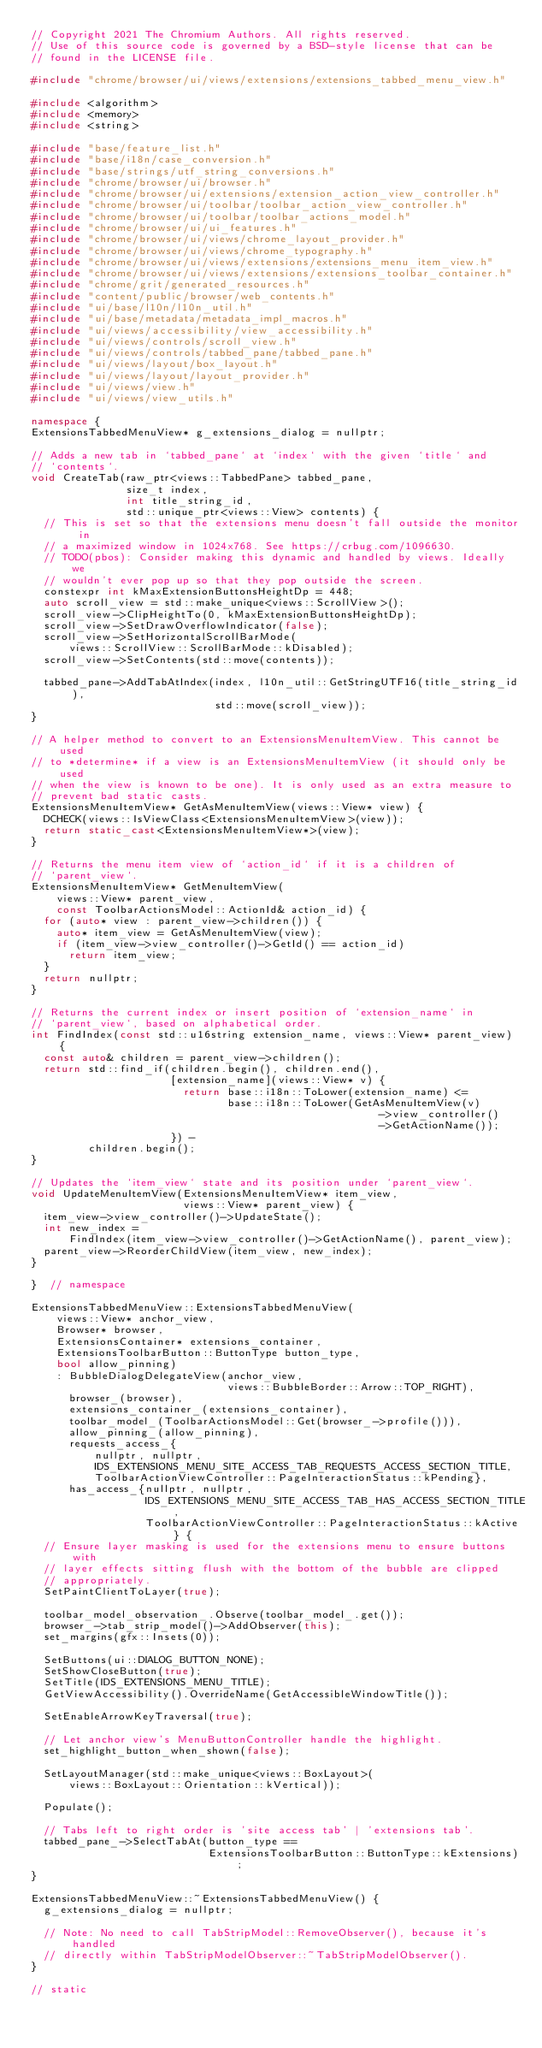Convert code to text. <code><loc_0><loc_0><loc_500><loc_500><_C++_>// Copyright 2021 The Chromium Authors. All rights reserved.
// Use of this source code is governed by a BSD-style license that can be
// found in the LICENSE file.

#include "chrome/browser/ui/views/extensions/extensions_tabbed_menu_view.h"

#include <algorithm>
#include <memory>
#include <string>

#include "base/feature_list.h"
#include "base/i18n/case_conversion.h"
#include "base/strings/utf_string_conversions.h"
#include "chrome/browser/ui/browser.h"
#include "chrome/browser/ui/extensions/extension_action_view_controller.h"
#include "chrome/browser/ui/toolbar/toolbar_action_view_controller.h"
#include "chrome/browser/ui/toolbar/toolbar_actions_model.h"
#include "chrome/browser/ui/ui_features.h"
#include "chrome/browser/ui/views/chrome_layout_provider.h"
#include "chrome/browser/ui/views/chrome_typography.h"
#include "chrome/browser/ui/views/extensions/extensions_menu_item_view.h"
#include "chrome/browser/ui/views/extensions/extensions_toolbar_container.h"
#include "chrome/grit/generated_resources.h"
#include "content/public/browser/web_contents.h"
#include "ui/base/l10n/l10n_util.h"
#include "ui/base/metadata/metadata_impl_macros.h"
#include "ui/views/accessibility/view_accessibility.h"
#include "ui/views/controls/scroll_view.h"
#include "ui/views/controls/tabbed_pane/tabbed_pane.h"
#include "ui/views/layout/box_layout.h"
#include "ui/views/layout/layout_provider.h"
#include "ui/views/view.h"
#include "ui/views/view_utils.h"

namespace {
ExtensionsTabbedMenuView* g_extensions_dialog = nullptr;

// Adds a new tab in `tabbed_pane` at `index` with the given `title` and
// `contents`.
void CreateTab(raw_ptr<views::TabbedPane> tabbed_pane,
               size_t index,
               int title_string_id,
               std::unique_ptr<views::View> contents) {
  // This is set so that the extensions menu doesn't fall outside the monitor in
  // a maximized window in 1024x768. See https://crbug.com/1096630.
  // TODO(pbos): Consider making this dynamic and handled by views. Ideally we
  // wouldn't ever pop up so that they pop outside the screen.
  constexpr int kMaxExtensionButtonsHeightDp = 448;
  auto scroll_view = std::make_unique<views::ScrollView>();
  scroll_view->ClipHeightTo(0, kMaxExtensionButtonsHeightDp);
  scroll_view->SetDrawOverflowIndicator(false);
  scroll_view->SetHorizontalScrollBarMode(
      views::ScrollView::ScrollBarMode::kDisabled);
  scroll_view->SetContents(std::move(contents));

  tabbed_pane->AddTabAtIndex(index, l10n_util::GetStringUTF16(title_string_id),
                             std::move(scroll_view));
}

// A helper method to convert to an ExtensionsMenuItemView. This cannot be used
// to *determine* if a view is an ExtensionsMenuItemView (it should only be used
// when the view is known to be one). It is only used as an extra measure to
// prevent bad static casts.
ExtensionsMenuItemView* GetAsMenuItemView(views::View* view) {
  DCHECK(views::IsViewClass<ExtensionsMenuItemView>(view));
  return static_cast<ExtensionsMenuItemView*>(view);
}

// Returns the menu item view of `action_id` if it is a children of
// `parent_view`.
ExtensionsMenuItemView* GetMenuItemView(
    views::View* parent_view,
    const ToolbarActionsModel::ActionId& action_id) {
  for (auto* view : parent_view->children()) {
    auto* item_view = GetAsMenuItemView(view);
    if (item_view->view_controller()->GetId() == action_id)
      return item_view;
  }
  return nullptr;
}

// Returns the current index or insert position of `extension_name` in
// `parent_view`, based on alphabetical order.
int FindIndex(const std::u16string extension_name, views::View* parent_view) {
  const auto& children = parent_view->children();
  return std::find_if(children.begin(), children.end(),
                      [extension_name](views::View* v) {
                        return base::i18n::ToLower(extension_name) <=
                               base::i18n::ToLower(GetAsMenuItemView(v)
                                                       ->view_controller()
                                                       ->GetActionName());
                      }) -
         children.begin();
}

// Updates the `item_view` state and its position under `parent_view`.
void UpdateMenuItemView(ExtensionsMenuItemView* item_view,
                        views::View* parent_view) {
  item_view->view_controller()->UpdateState();
  int new_index =
      FindIndex(item_view->view_controller()->GetActionName(), parent_view);
  parent_view->ReorderChildView(item_view, new_index);
}

}  // namespace

ExtensionsTabbedMenuView::ExtensionsTabbedMenuView(
    views::View* anchor_view,
    Browser* browser,
    ExtensionsContainer* extensions_container,
    ExtensionsToolbarButton::ButtonType button_type,
    bool allow_pinning)
    : BubbleDialogDelegateView(anchor_view,
                               views::BubbleBorder::Arrow::TOP_RIGHT),
      browser_(browser),
      extensions_container_(extensions_container),
      toolbar_model_(ToolbarActionsModel::Get(browser_->profile())),
      allow_pinning_(allow_pinning),
      requests_access_{
          nullptr, nullptr,
          IDS_EXTENSIONS_MENU_SITE_ACCESS_TAB_REQUESTS_ACCESS_SECTION_TITLE,
          ToolbarActionViewController::PageInteractionStatus::kPending},
      has_access_{nullptr, nullptr,
                  IDS_EXTENSIONS_MENU_SITE_ACCESS_TAB_HAS_ACCESS_SECTION_TITLE,
                  ToolbarActionViewController::PageInteractionStatus::kActive} {
  // Ensure layer masking is used for the extensions menu to ensure buttons with
  // layer effects sitting flush with the bottom of the bubble are clipped
  // appropriately.
  SetPaintClientToLayer(true);

  toolbar_model_observation_.Observe(toolbar_model_.get());
  browser_->tab_strip_model()->AddObserver(this);
  set_margins(gfx::Insets(0));

  SetButtons(ui::DIALOG_BUTTON_NONE);
  SetShowCloseButton(true);
  SetTitle(IDS_EXTENSIONS_MENU_TITLE);
  GetViewAccessibility().OverrideName(GetAccessibleWindowTitle());

  SetEnableArrowKeyTraversal(true);

  // Let anchor view's MenuButtonController handle the highlight.
  set_highlight_button_when_shown(false);

  SetLayoutManager(std::make_unique<views::BoxLayout>(
      views::BoxLayout::Orientation::kVertical));

  Populate();

  // Tabs left to right order is 'site access tab' | 'extensions tab'.
  tabbed_pane_->SelectTabAt(button_type ==
                            ExtensionsToolbarButton::ButtonType::kExtensions);
}

ExtensionsTabbedMenuView::~ExtensionsTabbedMenuView() {
  g_extensions_dialog = nullptr;

  // Note: No need to call TabStripModel::RemoveObserver(), because it's handled
  // directly within TabStripModelObserver::~TabStripModelObserver().
}

// static</code> 